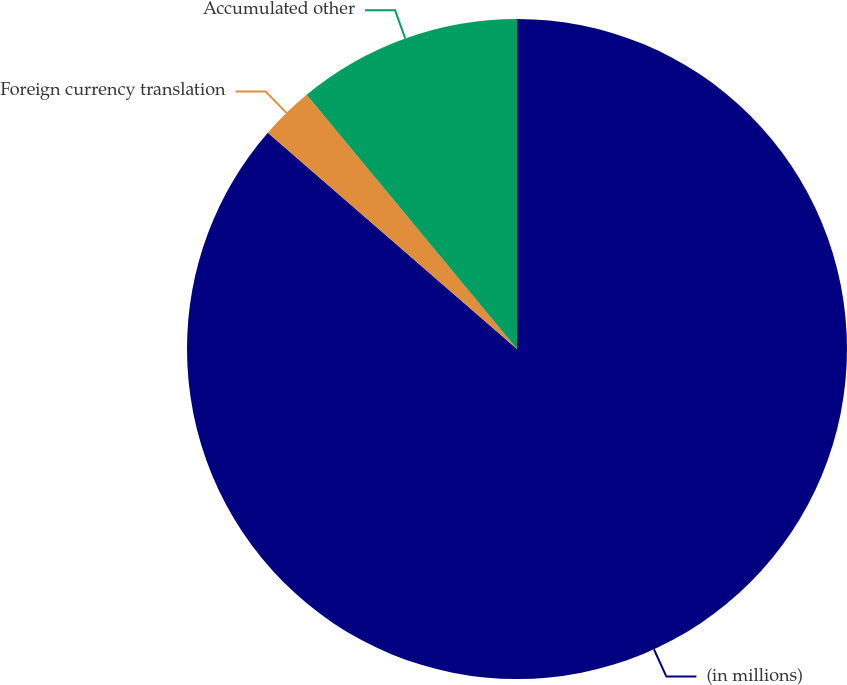Convert chart. <chart><loc_0><loc_0><loc_500><loc_500><pie_chart><fcel>(in millions)<fcel>Foreign currency translation<fcel>Accumulated other<nl><fcel>86.38%<fcel>2.62%<fcel>11.0%<nl></chart> 